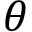<formula> <loc_0><loc_0><loc_500><loc_500>\theta</formula> 